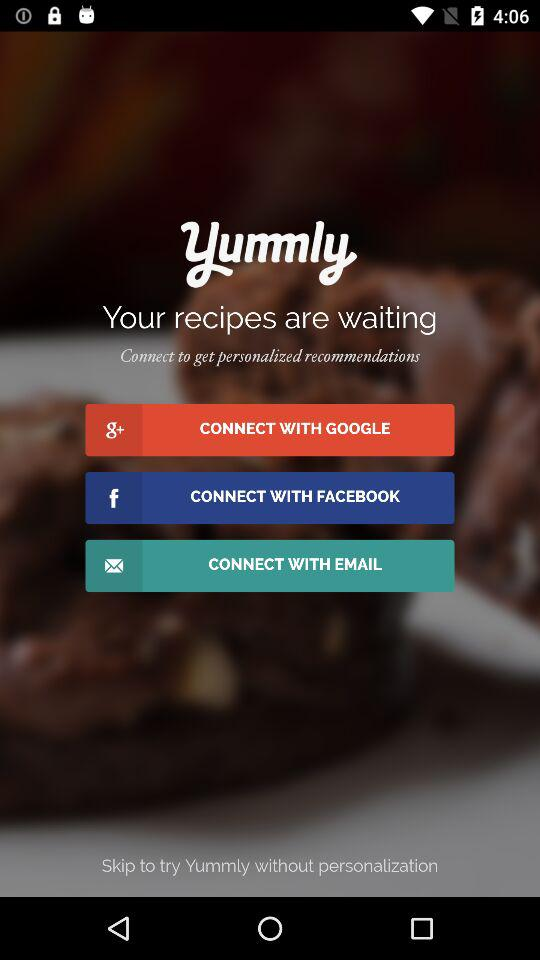How many ways can I connect to Yummly?
Answer the question using a single word or phrase. 3 